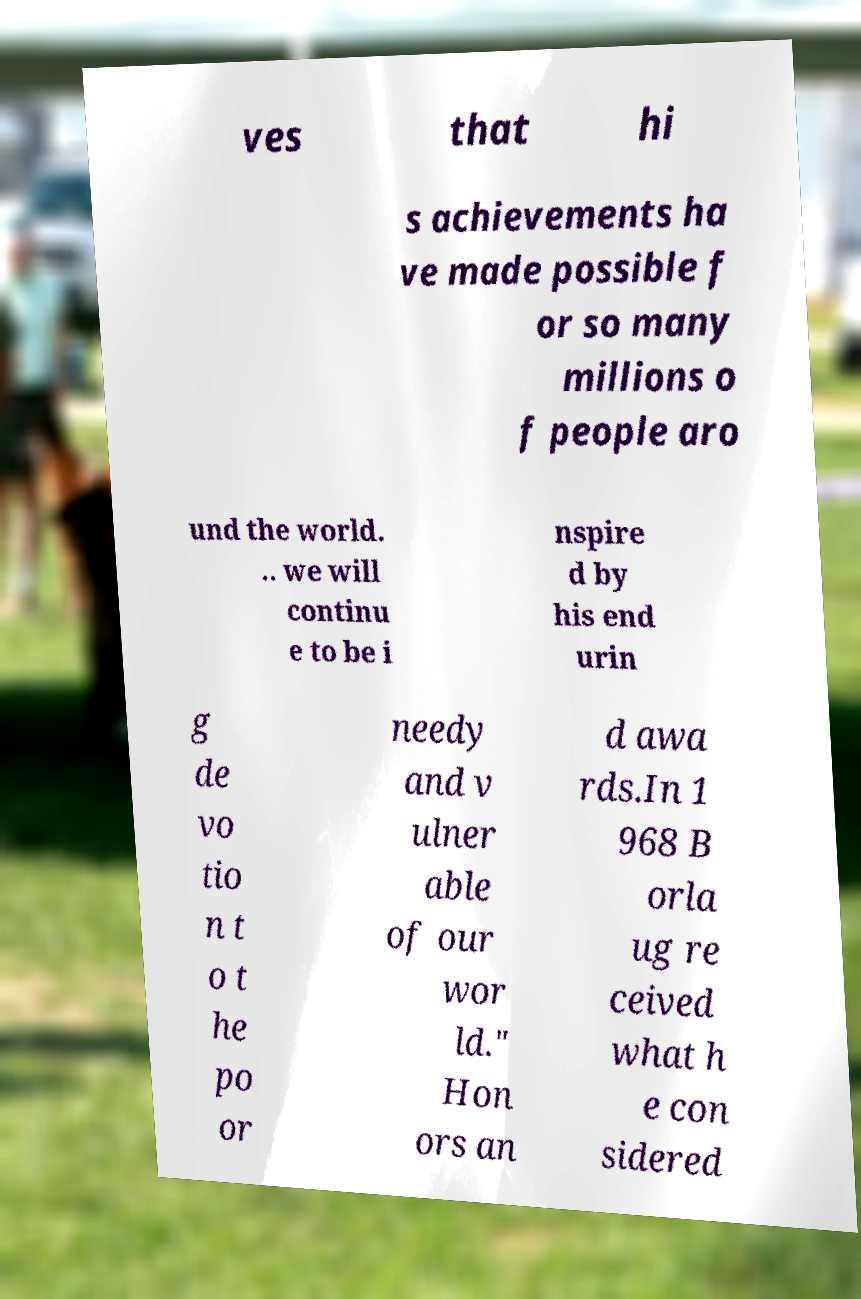Can you read and provide the text displayed in the image?This photo seems to have some interesting text. Can you extract and type it out for me? ves that hi s achievements ha ve made possible f or so many millions o f people aro und the world. .. we will continu e to be i nspire d by his end urin g de vo tio n t o t he po or needy and v ulner able of our wor ld." Hon ors an d awa rds.In 1 968 B orla ug re ceived what h e con sidered 